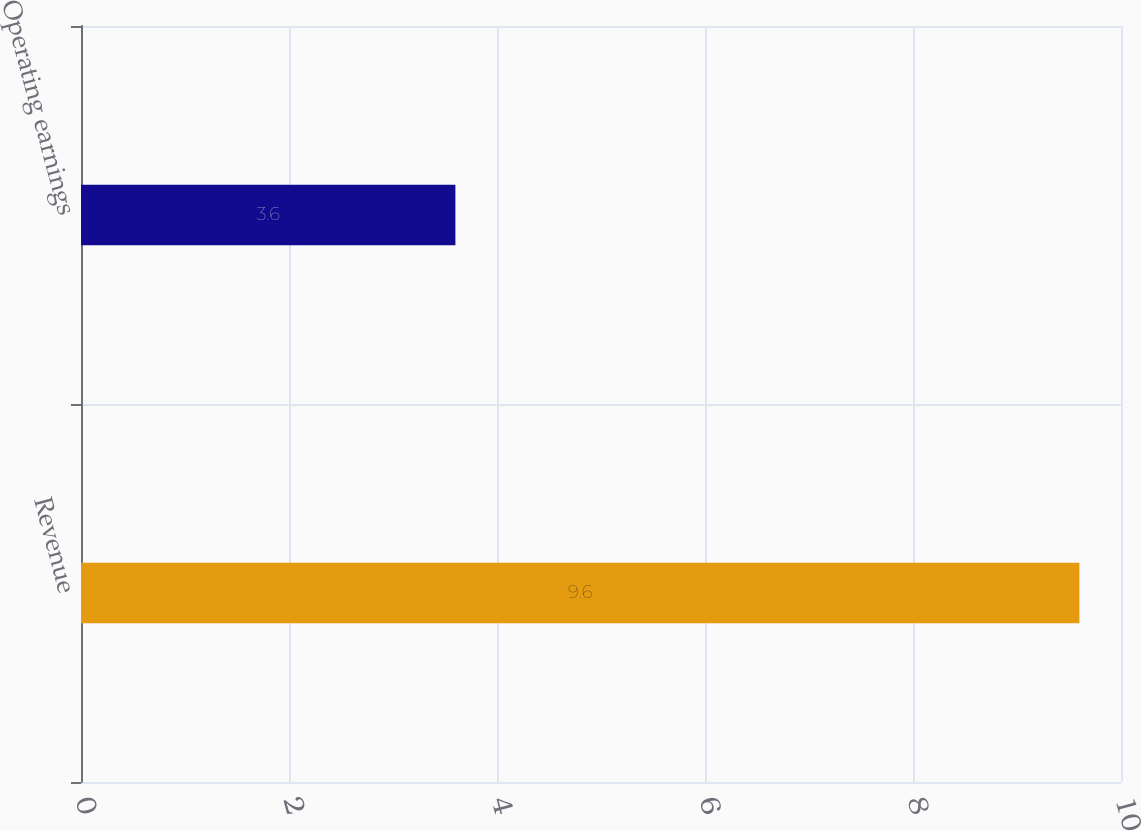<chart> <loc_0><loc_0><loc_500><loc_500><bar_chart><fcel>Revenue<fcel>Operating earnings<nl><fcel>9.6<fcel>3.6<nl></chart> 